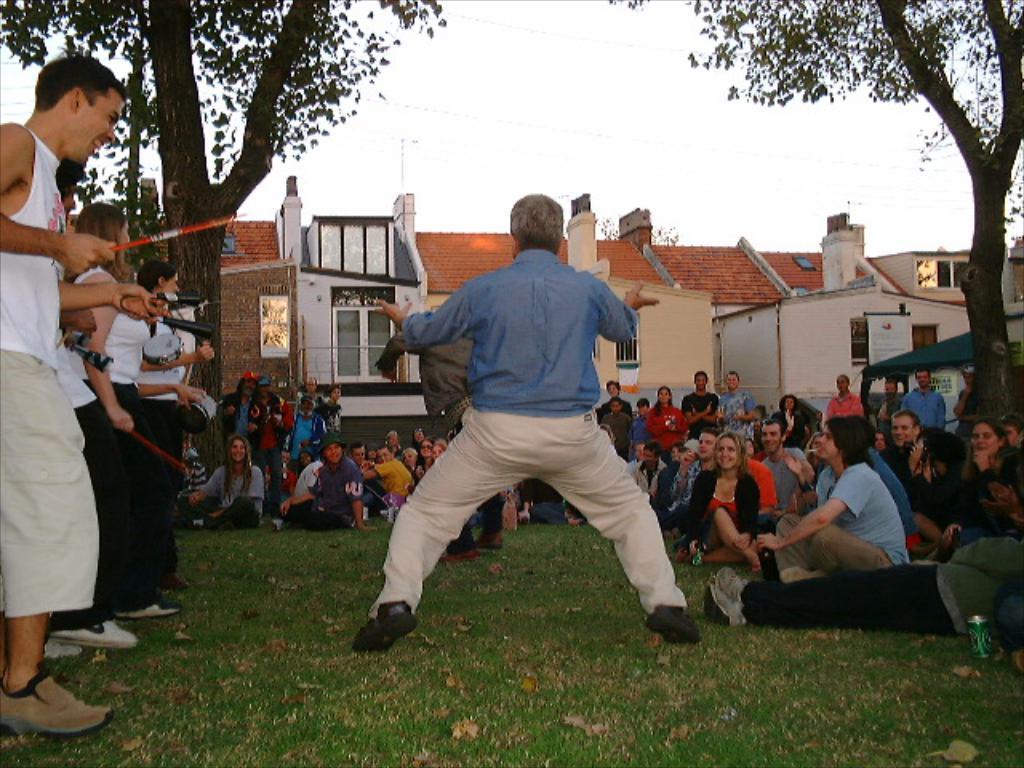Could you give a brief overview of what you see in this image? In this image we can see a group of people are sitting. A few people are standing and holding some object on the left most of the image. A person is dancing in the center of the image. There are a few houses and trees in the image. 